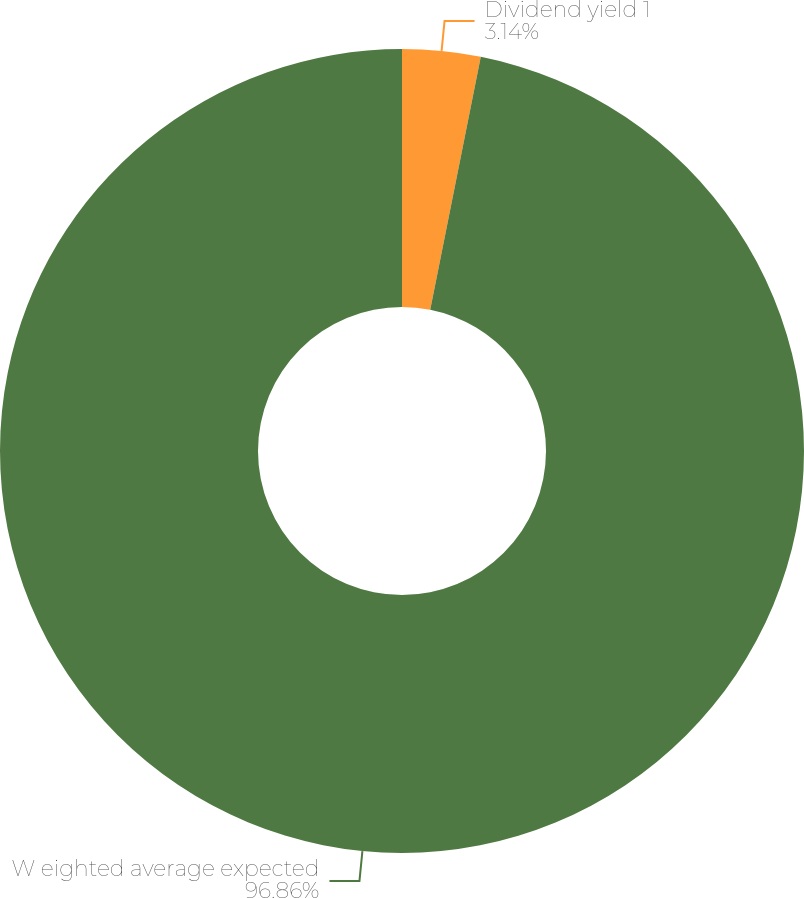Convert chart. <chart><loc_0><loc_0><loc_500><loc_500><pie_chart><fcel>Dividend yield 1<fcel>W eighted average expected<nl><fcel>3.14%<fcel>96.86%<nl></chart> 